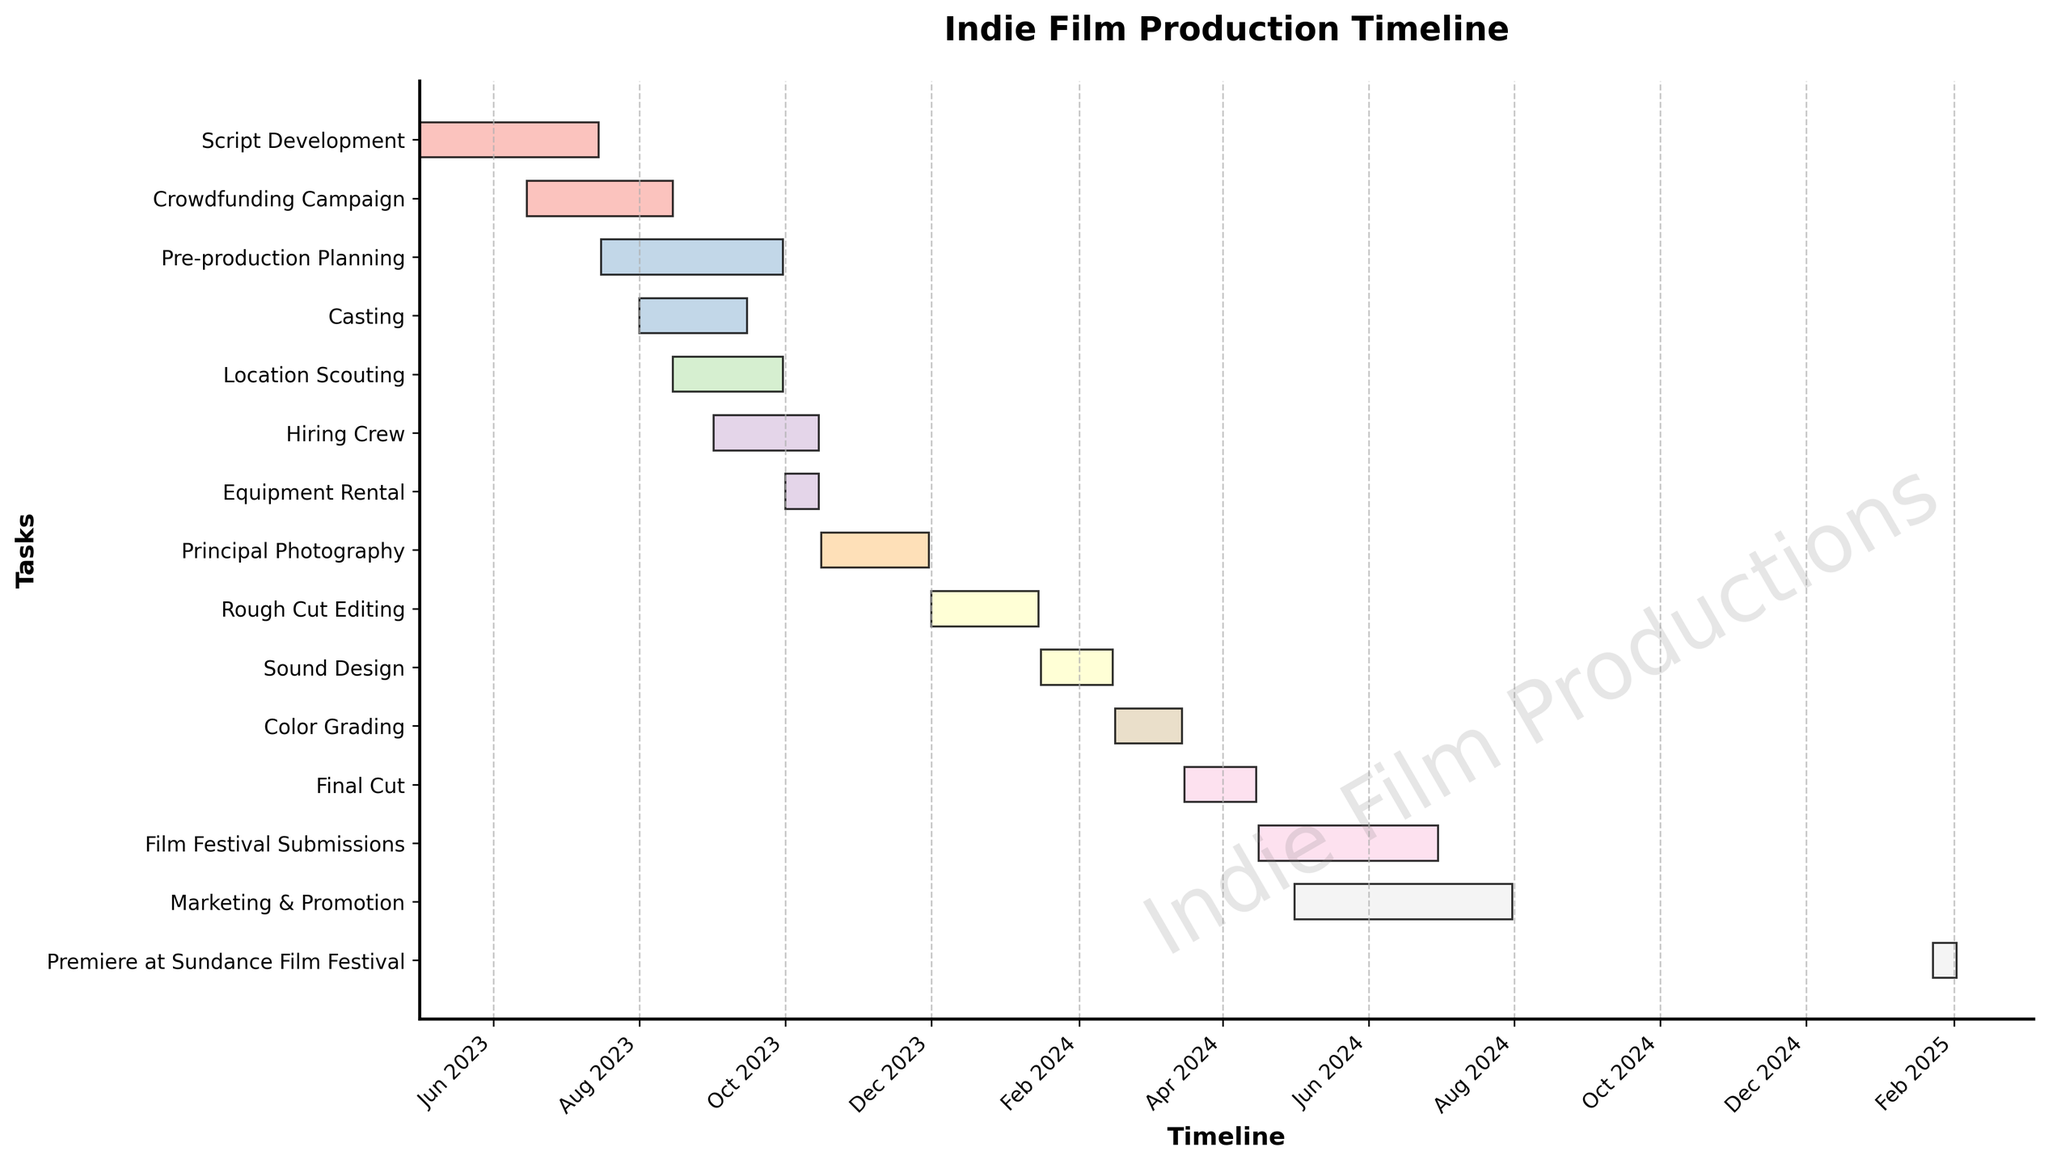Which task has the longest duration? To find the task with the longest duration, look at the length of the bars for each task. Principal Photography has the longest bar, indicating it has the longest duration.
Answer: Principal Photography When does Rough Cut Editing start and end? Find the bar labeled "Rough Cut Editing". The left edge represents the start date, and the right edge represents the end date. Rough Cut Editing starts on Dec 1, 2023 and ends on Jan 15, 2024.
Answer: Dec 1, 2023 to Jan 15, 2024 What's the total duration from Script Development to Final Cut? Look at the start date of Script Development and the end date of Final Cut. Script Development starts on May 1, 2023. Final Cut ends on Apr 15, 2024. Calculate the total duration by finding the difference between these dates.
Answer: May 1, 2023 to Apr 15, 2024 How many tasks are planned to take place in January 2024? Tasks occurring in January 2024 include segments of Rough Cut Editing, Sound Design, and continued Film Festival Submissions as well as the start of Marketing & Promotion. Count these tasks.
Answer: 4 tasks Which two tasks overlap the most? Check the bars that overlap the most on the timeline. Crowdfunding Campaign and Script Development overlap entirely for a significant duration.
Answer: Crowdfunding Campaign and Script Development What is the gap between the end of Principal Photography and the start of Rough Cut Editing? Note the end date of Principal Photography (Nov 30, 2023) and the start date of Rough Cut Editing (Dec 1, 2023). Subtract the end date from the start date.
Answer: 1 day Which task starts the latest on the timeline? Look for the bar that is positioned furthest to the right. The task "Premiere at Sundance Film Festival" starts the latest on Jan 23, 2025.
Answer: Premiere at Sundance Film Festival How long does the Film Festival Submissions phase last? Find the duration of the Film Festival Submissions bar by checking its start and end dates. It starts on Apr 16, 2024 and ends on Jun 30, 2024. Calculate the number of days between these dates.
Answer: 76 days Which tasks are in progress during October 2023? Identify the bars that span over October 2023. These tasks are Pre-production Planning, Casting, Location Scouting, Hiring Crew, and Equipment Rental.
Answer: 5 tasks What is the duration of the Marketing & Promotion phase? Check the start and end dates of the Marketing & Promotion bar. It starts on May 1, 2024 and ends on Jul 31, 2024. Calculate the duration by subtracting the start date from the end date.
Answer: 92 days 